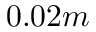<formula> <loc_0><loc_0><loc_500><loc_500>0 . 0 2 m</formula> 